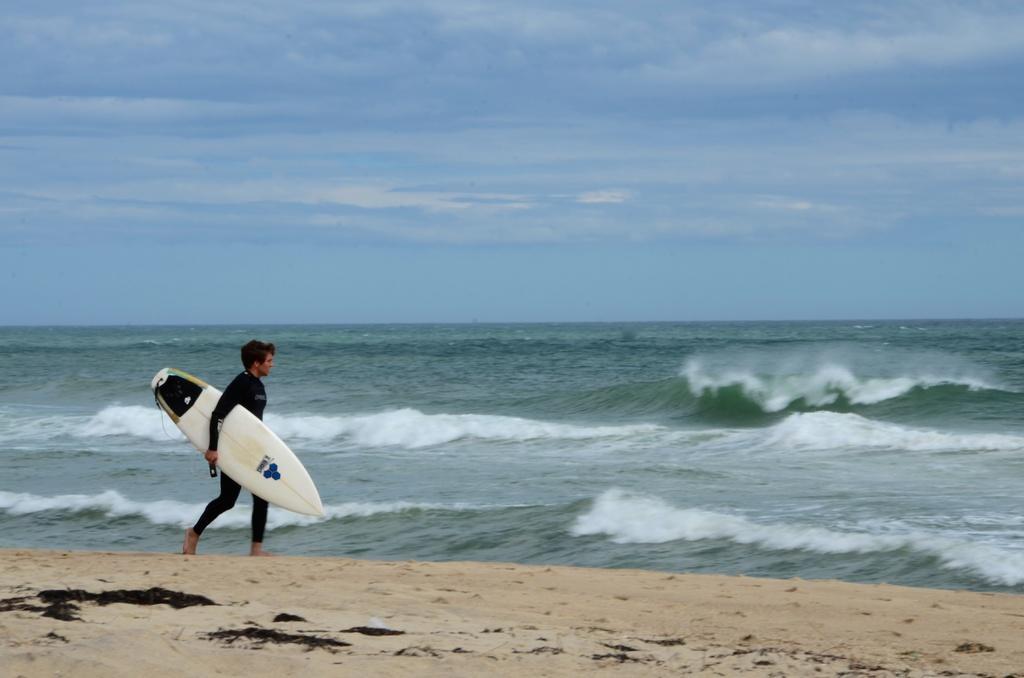Can you describe this image briefly? He is walking and his holding a skateboard. We can see in background sea and sky 